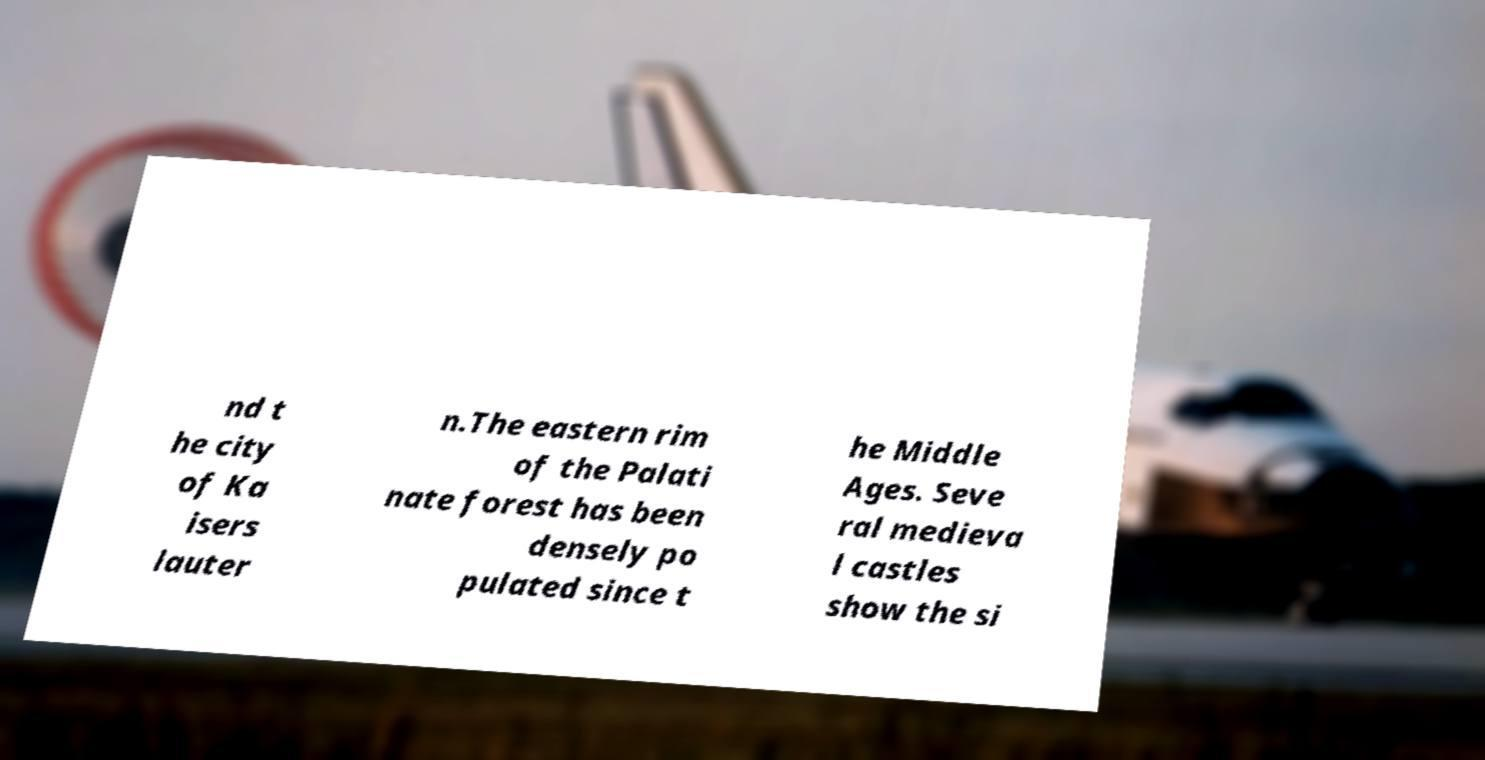Could you extract and type out the text from this image? nd t he city of Ka isers lauter n.The eastern rim of the Palati nate forest has been densely po pulated since t he Middle Ages. Seve ral medieva l castles show the si 